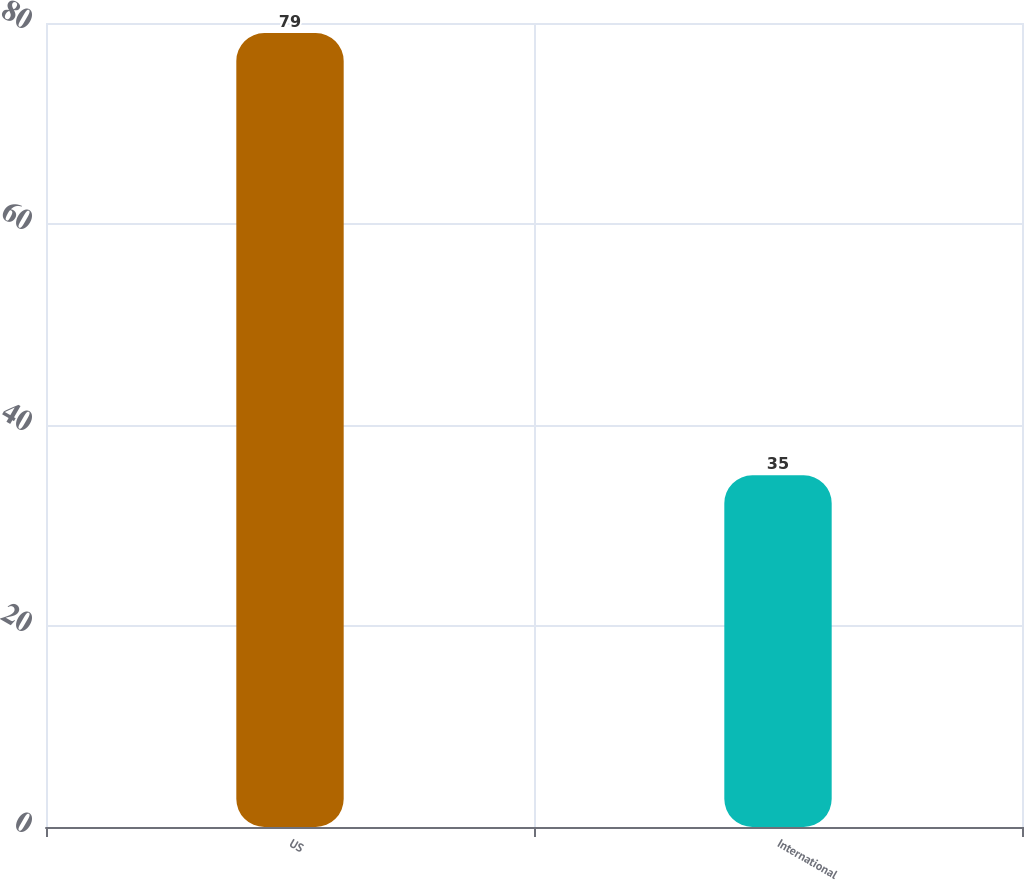Convert chart. <chart><loc_0><loc_0><loc_500><loc_500><bar_chart><fcel>US<fcel>International<nl><fcel>79<fcel>35<nl></chart> 